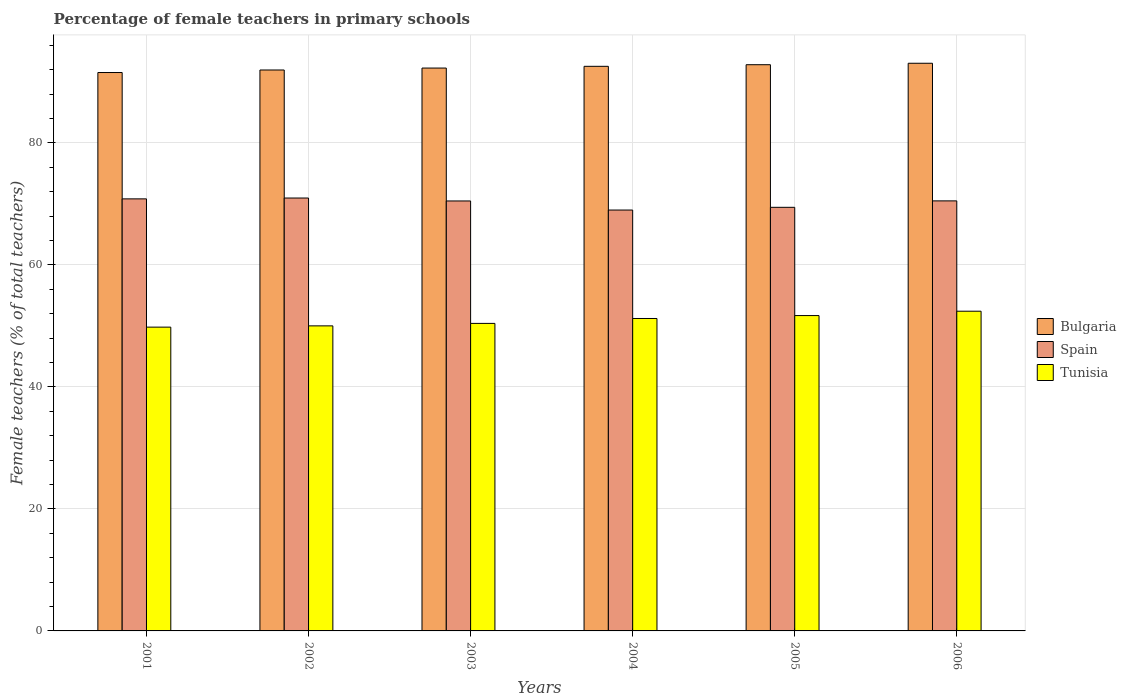How many groups of bars are there?
Provide a short and direct response. 6. What is the label of the 5th group of bars from the left?
Your answer should be compact. 2005. What is the percentage of female teachers in Bulgaria in 2006?
Provide a short and direct response. 93.06. Across all years, what is the maximum percentage of female teachers in Bulgaria?
Provide a short and direct response. 93.06. Across all years, what is the minimum percentage of female teachers in Tunisia?
Your response must be concise. 49.8. In which year was the percentage of female teachers in Spain maximum?
Ensure brevity in your answer.  2002. What is the total percentage of female teachers in Bulgaria in the graph?
Ensure brevity in your answer.  554.21. What is the difference between the percentage of female teachers in Spain in 2001 and that in 2002?
Your answer should be compact. -0.14. What is the difference between the percentage of female teachers in Spain in 2001 and the percentage of female teachers in Bulgaria in 2006?
Ensure brevity in your answer.  -22.23. What is the average percentage of female teachers in Tunisia per year?
Offer a terse response. 50.93. In the year 2002, what is the difference between the percentage of female teachers in Spain and percentage of female teachers in Bulgaria?
Ensure brevity in your answer.  -20.99. In how many years, is the percentage of female teachers in Spain greater than 16 %?
Offer a very short reply. 6. What is the ratio of the percentage of female teachers in Bulgaria in 2003 to that in 2004?
Provide a succinct answer. 1. What is the difference between the highest and the second highest percentage of female teachers in Bulgaria?
Keep it short and to the point. 0.24. What is the difference between the highest and the lowest percentage of female teachers in Spain?
Give a very brief answer. 1.97. In how many years, is the percentage of female teachers in Tunisia greater than the average percentage of female teachers in Tunisia taken over all years?
Provide a succinct answer. 3. What does the 3rd bar from the right in 2004 represents?
Ensure brevity in your answer.  Bulgaria. How many years are there in the graph?
Make the answer very short. 6. What is the difference between two consecutive major ticks on the Y-axis?
Make the answer very short. 20. Where does the legend appear in the graph?
Ensure brevity in your answer.  Center right. How many legend labels are there?
Offer a very short reply. 3. How are the legend labels stacked?
Your answer should be compact. Vertical. What is the title of the graph?
Offer a very short reply. Percentage of female teachers in primary schools. Does "Europe(developing only)" appear as one of the legend labels in the graph?
Your answer should be compact. No. What is the label or title of the Y-axis?
Offer a very short reply. Female teachers (% of total teachers). What is the Female teachers (% of total teachers) of Bulgaria in 2001?
Your answer should be very brief. 91.54. What is the Female teachers (% of total teachers) of Spain in 2001?
Provide a succinct answer. 70.83. What is the Female teachers (% of total teachers) in Tunisia in 2001?
Ensure brevity in your answer.  49.8. What is the Female teachers (% of total teachers) in Bulgaria in 2002?
Give a very brief answer. 91.96. What is the Female teachers (% of total teachers) of Spain in 2002?
Offer a terse response. 70.97. What is the Female teachers (% of total teachers) in Tunisia in 2002?
Provide a succinct answer. 50.01. What is the Female teachers (% of total teachers) of Bulgaria in 2003?
Keep it short and to the point. 92.27. What is the Female teachers (% of total teachers) of Spain in 2003?
Your answer should be compact. 70.49. What is the Female teachers (% of total teachers) in Tunisia in 2003?
Offer a terse response. 50.41. What is the Female teachers (% of total teachers) in Bulgaria in 2004?
Keep it short and to the point. 92.56. What is the Female teachers (% of total teachers) of Spain in 2004?
Offer a very short reply. 69. What is the Female teachers (% of total teachers) of Tunisia in 2004?
Make the answer very short. 51.22. What is the Female teachers (% of total teachers) of Bulgaria in 2005?
Ensure brevity in your answer.  92.82. What is the Female teachers (% of total teachers) of Spain in 2005?
Ensure brevity in your answer.  69.44. What is the Female teachers (% of total teachers) of Tunisia in 2005?
Provide a succinct answer. 51.7. What is the Female teachers (% of total teachers) of Bulgaria in 2006?
Keep it short and to the point. 93.06. What is the Female teachers (% of total teachers) of Spain in 2006?
Your answer should be compact. 70.5. What is the Female teachers (% of total teachers) in Tunisia in 2006?
Make the answer very short. 52.41. Across all years, what is the maximum Female teachers (% of total teachers) in Bulgaria?
Your response must be concise. 93.06. Across all years, what is the maximum Female teachers (% of total teachers) in Spain?
Provide a succinct answer. 70.97. Across all years, what is the maximum Female teachers (% of total teachers) of Tunisia?
Your answer should be compact. 52.41. Across all years, what is the minimum Female teachers (% of total teachers) of Bulgaria?
Offer a very short reply. 91.54. Across all years, what is the minimum Female teachers (% of total teachers) in Spain?
Make the answer very short. 69. Across all years, what is the minimum Female teachers (% of total teachers) in Tunisia?
Offer a very short reply. 49.8. What is the total Female teachers (% of total teachers) of Bulgaria in the graph?
Provide a short and direct response. 554.21. What is the total Female teachers (% of total teachers) in Spain in the graph?
Your response must be concise. 421.22. What is the total Female teachers (% of total teachers) in Tunisia in the graph?
Offer a very short reply. 305.55. What is the difference between the Female teachers (% of total teachers) in Bulgaria in 2001 and that in 2002?
Give a very brief answer. -0.42. What is the difference between the Female teachers (% of total teachers) of Spain in 2001 and that in 2002?
Provide a short and direct response. -0.14. What is the difference between the Female teachers (% of total teachers) in Tunisia in 2001 and that in 2002?
Provide a succinct answer. -0.21. What is the difference between the Female teachers (% of total teachers) of Bulgaria in 2001 and that in 2003?
Your response must be concise. -0.73. What is the difference between the Female teachers (% of total teachers) of Spain in 2001 and that in 2003?
Provide a short and direct response. 0.34. What is the difference between the Female teachers (% of total teachers) of Tunisia in 2001 and that in 2003?
Offer a terse response. -0.61. What is the difference between the Female teachers (% of total teachers) of Bulgaria in 2001 and that in 2004?
Your answer should be compact. -1.02. What is the difference between the Female teachers (% of total teachers) in Spain in 2001 and that in 2004?
Ensure brevity in your answer.  1.83. What is the difference between the Female teachers (% of total teachers) of Tunisia in 2001 and that in 2004?
Offer a very short reply. -1.42. What is the difference between the Female teachers (% of total teachers) in Bulgaria in 2001 and that in 2005?
Keep it short and to the point. -1.28. What is the difference between the Female teachers (% of total teachers) in Spain in 2001 and that in 2005?
Your response must be concise. 1.39. What is the difference between the Female teachers (% of total teachers) in Tunisia in 2001 and that in 2005?
Ensure brevity in your answer.  -1.9. What is the difference between the Female teachers (% of total teachers) in Bulgaria in 2001 and that in 2006?
Provide a short and direct response. -1.52. What is the difference between the Female teachers (% of total teachers) of Spain in 2001 and that in 2006?
Offer a terse response. 0.33. What is the difference between the Female teachers (% of total teachers) in Tunisia in 2001 and that in 2006?
Keep it short and to the point. -2.61. What is the difference between the Female teachers (% of total teachers) in Bulgaria in 2002 and that in 2003?
Provide a succinct answer. -0.32. What is the difference between the Female teachers (% of total teachers) in Spain in 2002 and that in 2003?
Ensure brevity in your answer.  0.48. What is the difference between the Female teachers (% of total teachers) of Tunisia in 2002 and that in 2003?
Provide a succinct answer. -0.4. What is the difference between the Female teachers (% of total teachers) in Bulgaria in 2002 and that in 2004?
Provide a succinct answer. -0.6. What is the difference between the Female teachers (% of total teachers) of Spain in 2002 and that in 2004?
Your answer should be compact. 1.97. What is the difference between the Female teachers (% of total teachers) of Tunisia in 2002 and that in 2004?
Ensure brevity in your answer.  -1.21. What is the difference between the Female teachers (% of total teachers) in Bulgaria in 2002 and that in 2005?
Ensure brevity in your answer.  -0.86. What is the difference between the Female teachers (% of total teachers) in Spain in 2002 and that in 2005?
Your answer should be compact. 1.53. What is the difference between the Female teachers (% of total teachers) of Tunisia in 2002 and that in 2005?
Your answer should be compact. -1.69. What is the difference between the Female teachers (% of total teachers) in Bulgaria in 2002 and that in 2006?
Provide a short and direct response. -1.1. What is the difference between the Female teachers (% of total teachers) of Spain in 2002 and that in 2006?
Make the answer very short. 0.47. What is the difference between the Female teachers (% of total teachers) in Tunisia in 2002 and that in 2006?
Your response must be concise. -2.4. What is the difference between the Female teachers (% of total teachers) of Bulgaria in 2003 and that in 2004?
Keep it short and to the point. -0.29. What is the difference between the Female teachers (% of total teachers) of Spain in 2003 and that in 2004?
Offer a very short reply. 1.49. What is the difference between the Female teachers (% of total teachers) of Tunisia in 2003 and that in 2004?
Your answer should be compact. -0.8. What is the difference between the Female teachers (% of total teachers) in Bulgaria in 2003 and that in 2005?
Make the answer very short. -0.55. What is the difference between the Female teachers (% of total teachers) in Spain in 2003 and that in 2005?
Keep it short and to the point. 1.04. What is the difference between the Female teachers (% of total teachers) of Tunisia in 2003 and that in 2005?
Your answer should be compact. -1.28. What is the difference between the Female teachers (% of total teachers) in Bulgaria in 2003 and that in 2006?
Make the answer very short. -0.79. What is the difference between the Female teachers (% of total teachers) of Spain in 2003 and that in 2006?
Give a very brief answer. -0.01. What is the difference between the Female teachers (% of total teachers) of Tunisia in 2003 and that in 2006?
Your answer should be very brief. -2. What is the difference between the Female teachers (% of total teachers) in Bulgaria in 2004 and that in 2005?
Give a very brief answer. -0.26. What is the difference between the Female teachers (% of total teachers) of Spain in 2004 and that in 2005?
Your answer should be compact. -0.45. What is the difference between the Female teachers (% of total teachers) of Tunisia in 2004 and that in 2005?
Your answer should be very brief. -0.48. What is the difference between the Female teachers (% of total teachers) of Bulgaria in 2004 and that in 2006?
Offer a terse response. -0.5. What is the difference between the Female teachers (% of total teachers) of Spain in 2004 and that in 2006?
Offer a very short reply. -1.5. What is the difference between the Female teachers (% of total teachers) of Tunisia in 2004 and that in 2006?
Your answer should be very brief. -1.19. What is the difference between the Female teachers (% of total teachers) of Bulgaria in 2005 and that in 2006?
Offer a very short reply. -0.24. What is the difference between the Female teachers (% of total teachers) in Spain in 2005 and that in 2006?
Offer a terse response. -1.06. What is the difference between the Female teachers (% of total teachers) of Tunisia in 2005 and that in 2006?
Your answer should be compact. -0.71. What is the difference between the Female teachers (% of total teachers) of Bulgaria in 2001 and the Female teachers (% of total teachers) of Spain in 2002?
Offer a terse response. 20.57. What is the difference between the Female teachers (% of total teachers) in Bulgaria in 2001 and the Female teachers (% of total teachers) in Tunisia in 2002?
Your response must be concise. 41.53. What is the difference between the Female teachers (% of total teachers) of Spain in 2001 and the Female teachers (% of total teachers) of Tunisia in 2002?
Your answer should be very brief. 20.82. What is the difference between the Female teachers (% of total teachers) in Bulgaria in 2001 and the Female teachers (% of total teachers) in Spain in 2003?
Provide a short and direct response. 21.05. What is the difference between the Female teachers (% of total teachers) in Bulgaria in 2001 and the Female teachers (% of total teachers) in Tunisia in 2003?
Your answer should be compact. 41.13. What is the difference between the Female teachers (% of total teachers) of Spain in 2001 and the Female teachers (% of total teachers) of Tunisia in 2003?
Keep it short and to the point. 20.42. What is the difference between the Female teachers (% of total teachers) in Bulgaria in 2001 and the Female teachers (% of total teachers) in Spain in 2004?
Give a very brief answer. 22.54. What is the difference between the Female teachers (% of total teachers) in Bulgaria in 2001 and the Female teachers (% of total teachers) in Tunisia in 2004?
Keep it short and to the point. 40.32. What is the difference between the Female teachers (% of total teachers) of Spain in 2001 and the Female teachers (% of total teachers) of Tunisia in 2004?
Your answer should be very brief. 19.61. What is the difference between the Female teachers (% of total teachers) of Bulgaria in 2001 and the Female teachers (% of total teachers) of Spain in 2005?
Ensure brevity in your answer.  22.1. What is the difference between the Female teachers (% of total teachers) of Bulgaria in 2001 and the Female teachers (% of total teachers) of Tunisia in 2005?
Make the answer very short. 39.84. What is the difference between the Female teachers (% of total teachers) in Spain in 2001 and the Female teachers (% of total teachers) in Tunisia in 2005?
Give a very brief answer. 19.13. What is the difference between the Female teachers (% of total teachers) of Bulgaria in 2001 and the Female teachers (% of total teachers) of Spain in 2006?
Give a very brief answer. 21.04. What is the difference between the Female teachers (% of total teachers) of Bulgaria in 2001 and the Female teachers (% of total teachers) of Tunisia in 2006?
Offer a very short reply. 39.13. What is the difference between the Female teachers (% of total teachers) of Spain in 2001 and the Female teachers (% of total teachers) of Tunisia in 2006?
Offer a very short reply. 18.42. What is the difference between the Female teachers (% of total teachers) of Bulgaria in 2002 and the Female teachers (% of total teachers) of Spain in 2003?
Keep it short and to the point. 21.47. What is the difference between the Female teachers (% of total teachers) in Bulgaria in 2002 and the Female teachers (% of total teachers) in Tunisia in 2003?
Keep it short and to the point. 41.54. What is the difference between the Female teachers (% of total teachers) in Spain in 2002 and the Female teachers (% of total teachers) in Tunisia in 2003?
Your response must be concise. 20.55. What is the difference between the Female teachers (% of total teachers) in Bulgaria in 2002 and the Female teachers (% of total teachers) in Spain in 2004?
Offer a terse response. 22.96. What is the difference between the Female teachers (% of total teachers) in Bulgaria in 2002 and the Female teachers (% of total teachers) in Tunisia in 2004?
Provide a short and direct response. 40.74. What is the difference between the Female teachers (% of total teachers) of Spain in 2002 and the Female teachers (% of total teachers) of Tunisia in 2004?
Provide a short and direct response. 19.75. What is the difference between the Female teachers (% of total teachers) of Bulgaria in 2002 and the Female teachers (% of total teachers) of Spain in 2005?
Make the answer very short. 22.51. What is the difference between the Female teachers (% of total teachers) in Bulgaria in 2002 and the Female teachers (% of total teachers) in Tunisia in 2005?
Make the answer very short. 40.26. What is the difference between the Female teachers (% of total teachers) in Spain in 2002 and the Female teachers (% of total teachers) in Tunisia in 2005?
Your response must be concise. 19.27. What is the difference between the Female teachers (% of total teachers) in Bulgaria in 2002 and the Female teachers (% of total teachers) in Spain in 2006?
Ensure brevity in your answer.  21.46. What is the difference between the Female teachers (% of total teachers) of Bulgaria in 2002 and the Female teachers (% of total teachers) of Tunisia in 2006?
Offer a very short reply. 39.55. What is the difference between the Female teachers (% of total teachers) in Spain in 2002 and the Female teachers (% of total teachers) in Tunisia in 2006?
Your response must be concise. 18.56. What is the difference between the Female teachers (% of total teachers) of Bulgaria in 2003 and the Female teachers (% of total teachers) of Spain in 2004?
Provide a succinct answer. 23.28. What is the difference between the Female teachers (% of total teachers) in Bulgaria in 2003 and the Female teachers (% of total teachers) in Tunisia in 2004?
Your response must be concise. 41.06. What is the difference between the Female teachers (% of total teachers) of Spain in 2003 and the Female teachers (% of total teachers) of Tunisia in 2004?
Your answer should be compact. 19.27. What is the difference between the Female teachers (% of total teachers) in Bulgaria in 2003 and the Female teachers (% of total teachers) in Spain in 2005?
Make the answer very short. 22.83. What is the difference between the Female teachers (% of total teachers) of Bulgaria in 2003 and the Female teachers (% of total teachers) of Tunisia in 2005?
Offer a very short reply. 40.58. What is the difference between the Female teachers (% of total teachers) in Spain in 2003 and the Female teachers (% of total teachers) in Tunisia in 2005?
Ensure brevity in your answer.  18.79. What is the difference between the Female teachers (% of total teachers) of Bulgaria in 2003 and the Female teachers (% of total teachers) of Spain in 2006?
Keep it short and to the point. 21.77. What is the difference between the Female teachers (% of total teachers) in Bulgaria in 2003 and the Female teachers (% of total teachers) in Tunisia in 2006?
Offer a very short reply. 39.86. What is the difference between the Female teachers (% of total teachers) of Spain in 2003 and the Female teachers (% of total teachers) of Tunisia in 2006?
Provide a short and direct response. 18.07. What is the difference between the Female teachers (% of total teachers) in Bulgaria in 2004 and the Female teachers (% of total teachers) in Spain in 2005?
Offer a very short reply. 23.12. What is the difference between the Female teachers (% of total teachers) in Bulgaria in 2004 and the Female teachers (% of total teachers) in Tunisia in 2005?
Keep it short and to the point. 40.86. What is the difference between the Female teachers (% of total teachers) in Spain in 2004 and the Female teachers (% of total teachers) in Tunisia in 2005?
Your answer should be very brief. 17.3. What is the difference between the Female teachers (% of total teachers) in Bulgaria in 2004 and the Female teachers (% of total teachers) in Spain in 2006?
Offer a very short reply. 22.06. What is the difference between the Female teachers (% of total teachers) in Bulgaria in 2004 and the Female teachers (% of total teachers) in Tunisia in 2006?
Provide a succinct answer. 40.15. What is the difference between the Female teachers (% of total teachers) in Spain in 2004 and the Female teachers (% of total teachers) in Tunisia in 2006?
Offer a very short reply. 16.59. What is the difference between the Female teachers (% of total teachers) in Bulgaria in 2005 and the Female teachers (% of total teachers) in Spain in 2006?
Keep it short and to the point. 22.32. What is the difference between the Female teachers (% of total teachers) in Bulgaria in 2005 and the Female teachers (% of total teachers) in Tunisia in 2006?
Offer a terse response. 40.41. What is the difference between the Female teachers (% of total teachers) of Spain in 2005 and the Female teachers (% of total teachers) of Tunisia in 2006?
Your answer should be compact. 17.03. What is the average Female teachers (% of total teachers) of Bulgaria per year?
Give a very brief answer. 92.37. What is the average Female teachers (% of total teachers) in Spain per year?
Keep it short and to the point. 70.2. What is the average Female teachers (% of total teachers) in Tunisia per year?
Your answer should be very brief. 50.93. In the year 2001, what is the difference between the Female teachers (% of total teachers) in Bulgaria and Female teachers (% of total teachers) in Spain?
Keep it short and to the point. 20.71. In the year 2001, what is the difference between the Female teachers (% of total teachers) of Bulgaria and Female teachers (% of total teachers) of Tunisia?
Offer a very short reply. 41.74. In the year 2001, what is the difference between the Female teachers (% of total teachers) in Spain and Female teachers (% of total teachers) in Tunisia?
Provide a short and direct response. 21.03. In the year 2002, what is the difference between the Female teachers (% of total teachers) in Bulgaria and Female teachers (% of total teachers) in Spain?
Make the answer very short. 20.99. In the year 2002, what is the difference between the Female teachers (% of total teachers) of Bulgaria and Female teachers (% of total teachers) of Tunisia?
Provide a succinct answer. 41.95. In the year 2002, what is the difference between the Female teachers (% of total teachers) in Spain and Female teachers (% of total teachers) in Tunisia?
Offer a terse response. 20.96. In the year 2003, what is the difference between the Female teachers (% of total teachers) in Bulgaria and Female teachers (% of total teachers) in Spain?
Offer a terse response. 21.79. In the year 2003, what is the difference between the Female teachers (% of total teachers) of Bulgaria and Female teachers (% of total teachers) of Tunisia?
Offer a very short reply. 41.86. In the year 2003, what is the difference between the Female teachers (% of total teachers) of Spain and Female teachers (% of total teachers) of Tunisia?
Give a very brief answer. 20.07. In the year 2004, what is the difference between the Female teachers (% of total teachers) of Bulgaria and Female teachers (% of total teachers) of Spain?
Your answer should be very brief. 23.56. In the year 2004, what is the difference between the Female teachers (% of total teachers) in Bulgaria and Female teachers (% of total teachers) in Tunisia?
Provide a short and direct response. 41.34. In the year 2004, what is the difference between the Female teachers (% of total teachers) of Spain and Female teachers (% of total teachers) of Tunisia?
Offer a terse response. 17.78. In the year 2005, what is the difference between the Female teachers (% of total teachers) of Bulgaria and Female teachers (% of total teachers) of Spain?
Give a very brief answer. 23.38. In the year 2005, what is the difference between the Female teachers (% of total teachers) in Bulgaria and Female teachers (% of total teachers) in Tunisia?
Provide a short and direct response. 41.12. In the year 2005, what is the difference between the Female teachers (% of total teachers) of Spain and Female teachers (% of total teachers) of Tunisia?
Your answer should be very brief. 17.74. In the year 2006, what is the difference between the Female teachers (% of total teachers) in Bulgaria and Female teachers (% of total teachers) in Spain?
Provide a succinct answer. 22.56. In the year 2006, what is the difference between the Female teachers (% of total teachers) of Bulgaria and Female teachers (% of total teachers) of Tunisia?
Give a very brief answer. 40.65. In the year 2006, what is the difference between the Female teachers (% of total teachers) in Spain and Female teachers (% of total teachers) in Tunisia?
Provide a short and direct response. 18.09. What is the ratio of the Female teachers (% of total teachers) in Bulgaria in 2001 to that in 2002?
Offer a very short reply. 1. What is the ratio of the Female teachers (% of total teachers) of Spain in 2001 to that in 2003?
Provide a succinct answer. 1. What is the ratio of the Female teachers (% of total teachers) of Tunisia in 2001 to that in 2003?
Make the answer very short. 0.99. What is the ratio of the Female teachers (% of total teachers) in Bulgaria in 2001 to that in 2004?
Provide a succinct answer. 0.99. What is the ratio of the Female teachers (% of total teachers) of Spain in 2001 to that in 2004?
Offer a terse response. 1.03. What is the ratio of the Female teachers (% of total teachers) in Tunisia in 2001 to that in 2004?
Ensure brevity in your answer.  0.97. What is the ratio of the Female teachers (% of total teachers) of Bulgaria in 2001 to that in 2005?
Your answer should be very brief. 0.99. What is the ratio of the Female teachers (% of total teachers) in Spain in 2001 to that in 2005?
Your answer should be compact. 1.02. What is the ratio of the Female teachers (% of total teachers) in Tunisia in 2001 to that in 2005?
Offer a very short reply. 0.96. What is the ratio of the Female teachers (% of total teachers) of Bulgaria in 2001 to that in 2006?
Your answer should be compact. 0.98. What is the ratio of the Female teachers (% of total teachers) in Tunisia in 2001 to that in 2006?
Give a very brief answer. 0.95. What is the ratio of the Female teachers (% of total teachers) of Spain in 2002 to that in 2003?
Give a very brief answer. 1.01. What is the ratio of the Female teachers (% of total teachers) of Spain in 2002 to that in 2004?
Offer a terse response. 1.03. What is the ratio of the Female teachers (% of total teachers) in Tunisia in 2002 to that in 2004?
Your answer should be very brief. 0.98. What is the ratio of the Female teachers (% of total teachers) in Bulgaria in 2002 to that in 2005?
Provide a short and direct response. 0.99. What is the ratio of the Female teachers (% of total teachers) in Spain in 2002 to that in 2005?
Provide a short and direct response. 1.02. What is the ratio of the Female teachers (% of total teachers) in Tunisia in 2002 to that in 2005?
Make the answer very short. 0.97. What is the ratio of the Female teachers (% of total teachers) of Bulgaria in 2002 to that in 2006?
Offer a terse response. 0.99. What is the ratio of the Female teachers (% of total teachers) in Tunisia in 2002 to that in 2006?
Your answer should be very brief. 0.95. What is the ratio of the Female teachers (% of total teachers) of Bulgaria in 2003 to that in 2004?
Your answer should be compact. 1. What is the ratio of the Female teachers (% of total teachers) of Spain in 2003 to that in 2004?
Provide a succinct answer. 1.02. What is the ratio of the Female teachers (% of total teachers) of Tunisia in 2003 to that in 2004?
Make the answer very short. 0.98. What is the ratio of the Female teachers (% of total teachers) in Bulgaria in 2003 to that in 2005?
Provide a succinct answer. 0.99. What is the ratio of the Female teachers (% of total teachers) of Tunisia in 2003 to that in 2005?
Your answer should be compact. 0.98. What is the ratio of the Female teachers (% of total teachers) in Spain in 2003 to that in 2006?
Your answer should be compact. 1. What is the ratio of the Female teachers (% of total teachers) in Tunisia in 2003 to that in 2006?
Give a very brief answer. 0.96. What is the ratio of the Female teachers (% of total teachers) in Bulgaria in 2004 to that in 2005?
Give a very brief answer. 1. What is the ratio of the Female teachers (% of total teachers) in Spain in 2004 to that in 2006?
Offer a terse response. 0.98. What is the ratio of the Female teachers (% of total teachers) of Tunisia in 2004 to that in 2006?
Your answer should be compact. 0.98. What is the ratio of the Female teachers (% of total teachers) in Bulgaria in 2005 to that in 2006?
Offer a very short reply. 1. What is the ratio of the Female teachers (% of total teachers) in Tunisia in 2005 to that in 2006?
Make the answer very short. 0.99. What is the difference between the highest and the second highest Female teachers (% of total teachers) in Bulgaria?
Your answer should be compact. 0.24. What is the difference between the highest and the second highest Female teachers (% of total teachers) in Spain?
Provide a short and direct response. 0.14. What is the difference between the highest and the second highest Female teachers (% of total teachers) in Tunisia?
Make the answer very short. 0.71. What is the difference between the highest and the lowest Female teachers (% of total teachers) in Bulgaria?
Offer a terse response. 1.52. What is the difference between the highest and the lowest Female teachers (% of total teachers) in Spain?
Your response must be concise. 1.97. What is the difference between the highest and the lowest Female teachers (% of total teachers) in Tunisia?
Provide a succinct answer. 2.61. 